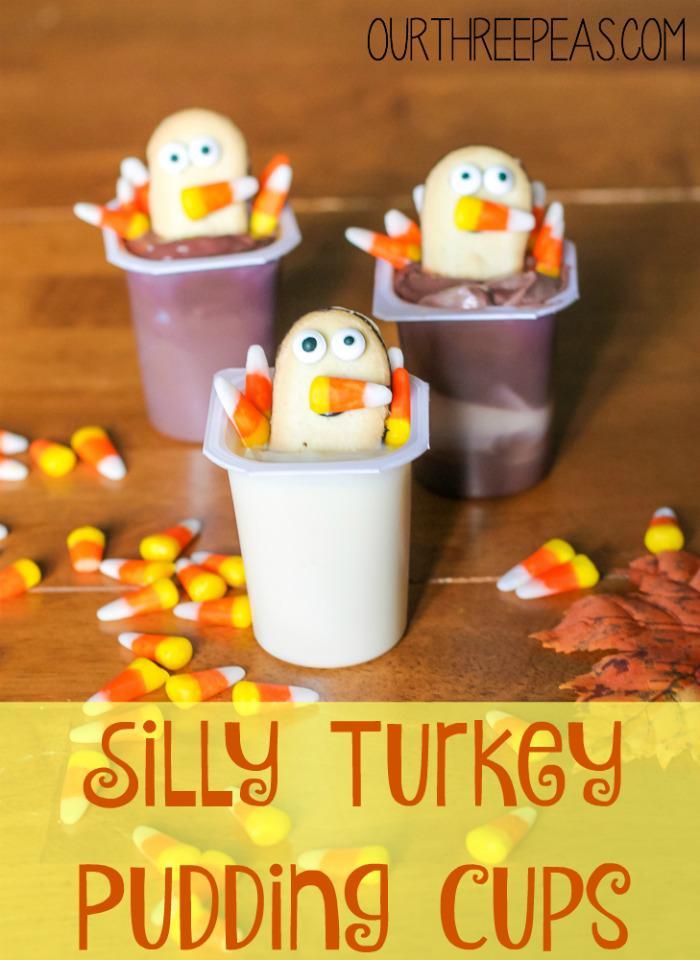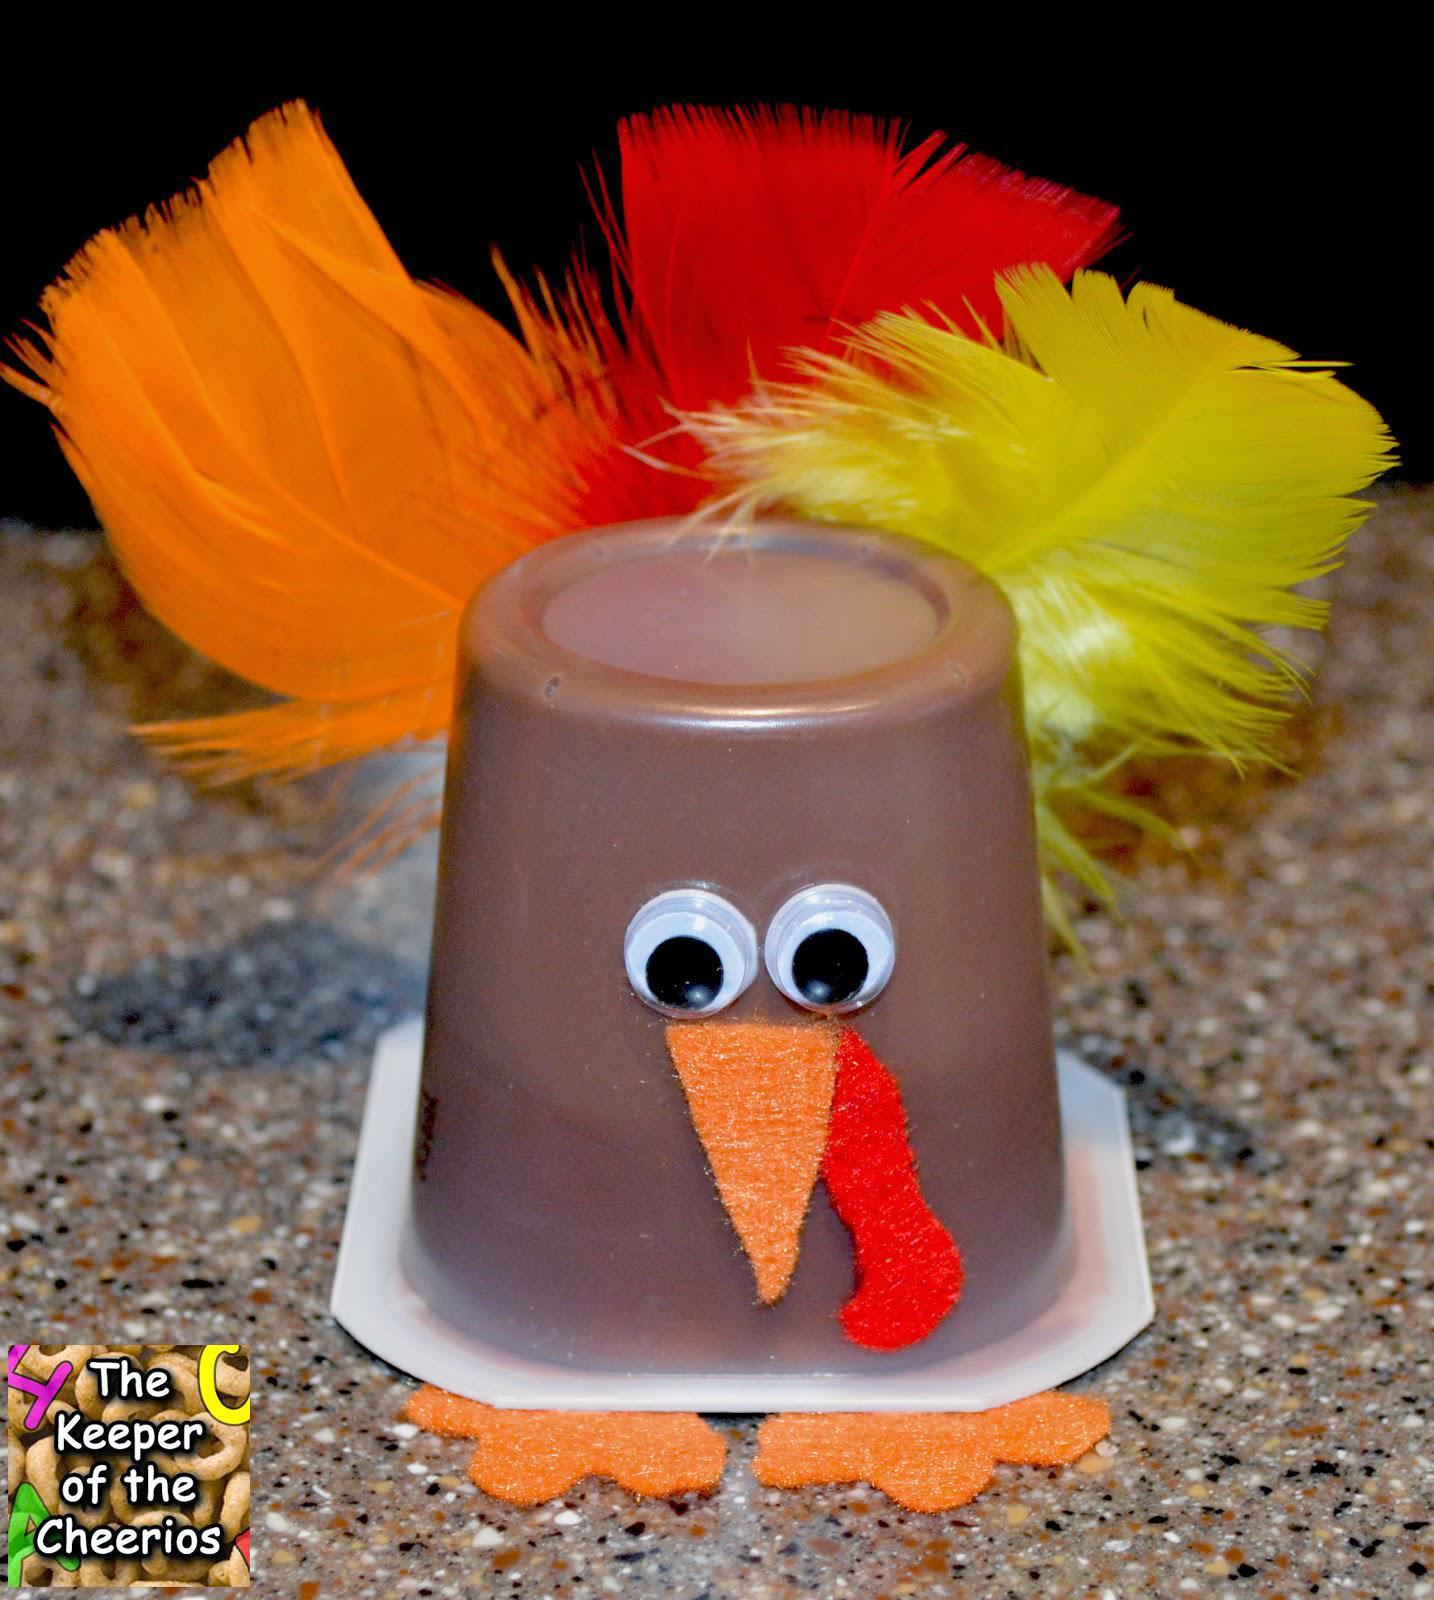The first image is the image on the left, the second image is the image on the right. For the images displayed, is the sentence "The left and right image contains a total of four pudding cups with turkey faces." factually correct? Answer yes or no. Yes. The first image is the image on the left, the second image is the image on the right. For the images shown, is this caption "One image shows three pudding cup 'turkeys' that are not in a single row, and the other image includes an inverted pudding cup with a turkey face and feathers." true? Answer yes or no. Yes. 